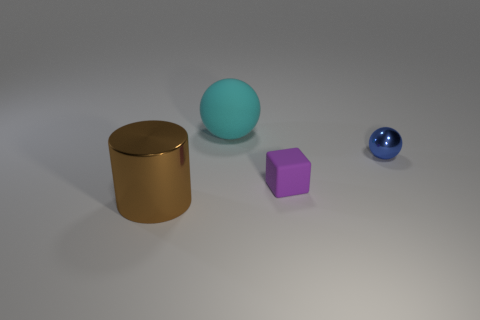How many rubber balls are the same size as the brown thing?
Keep it short and to the point. 1. There is a big cyan matte ball; how many purple rubber cubes are behind it?
Your response must be concise. 0. What is the big object behind the metallic thing left of the shiny sphere made of?
Your answer should be compact. Rubber. What size is the other object that is the same material as the brown object?
Ensure brevity in your answer.  Small. Are there any other things that have the same color as the big cylinder?
Keep it short and to the point. No. There is a ball that is to the right of the cyan rubber object; what is its color?
Offer a very short reply. Blue. Are there any cyan things that are on the left side of the shiny thing that is on the right side of the object behind the small blue object?
Make the answer very short. Yes. Are there more big brown metallic cylinders that are on the left side of the purple rubber object than blue cylinders?
Your answer should be very brief. Yes. There is a metallic object that is behind the brown metallic thing; does it have the same shape as the large rubber object?
Ensure brevity in your answer.  Yes. How many things are either large cyan shiny blocks or balls that are on the right side of the large cyan rubber ball?
Ensure brevity in your answer.  1. 